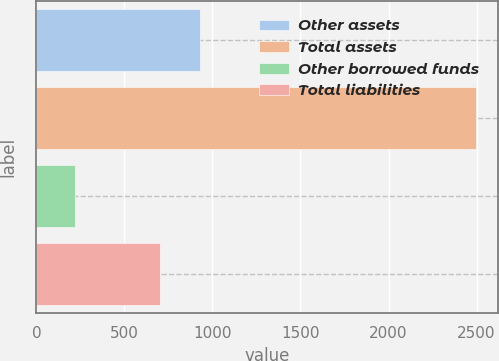<chart> <loc_0><loc_0><loc_500><loc_500><bar_chart><fcel>Other assets<fcel>Total assets<fcel>Other borrowed funds<fcel>Total liabilities<nl><fcel>929.8<fcel>2496<fcel>218<fcel>702<nl></chart> 